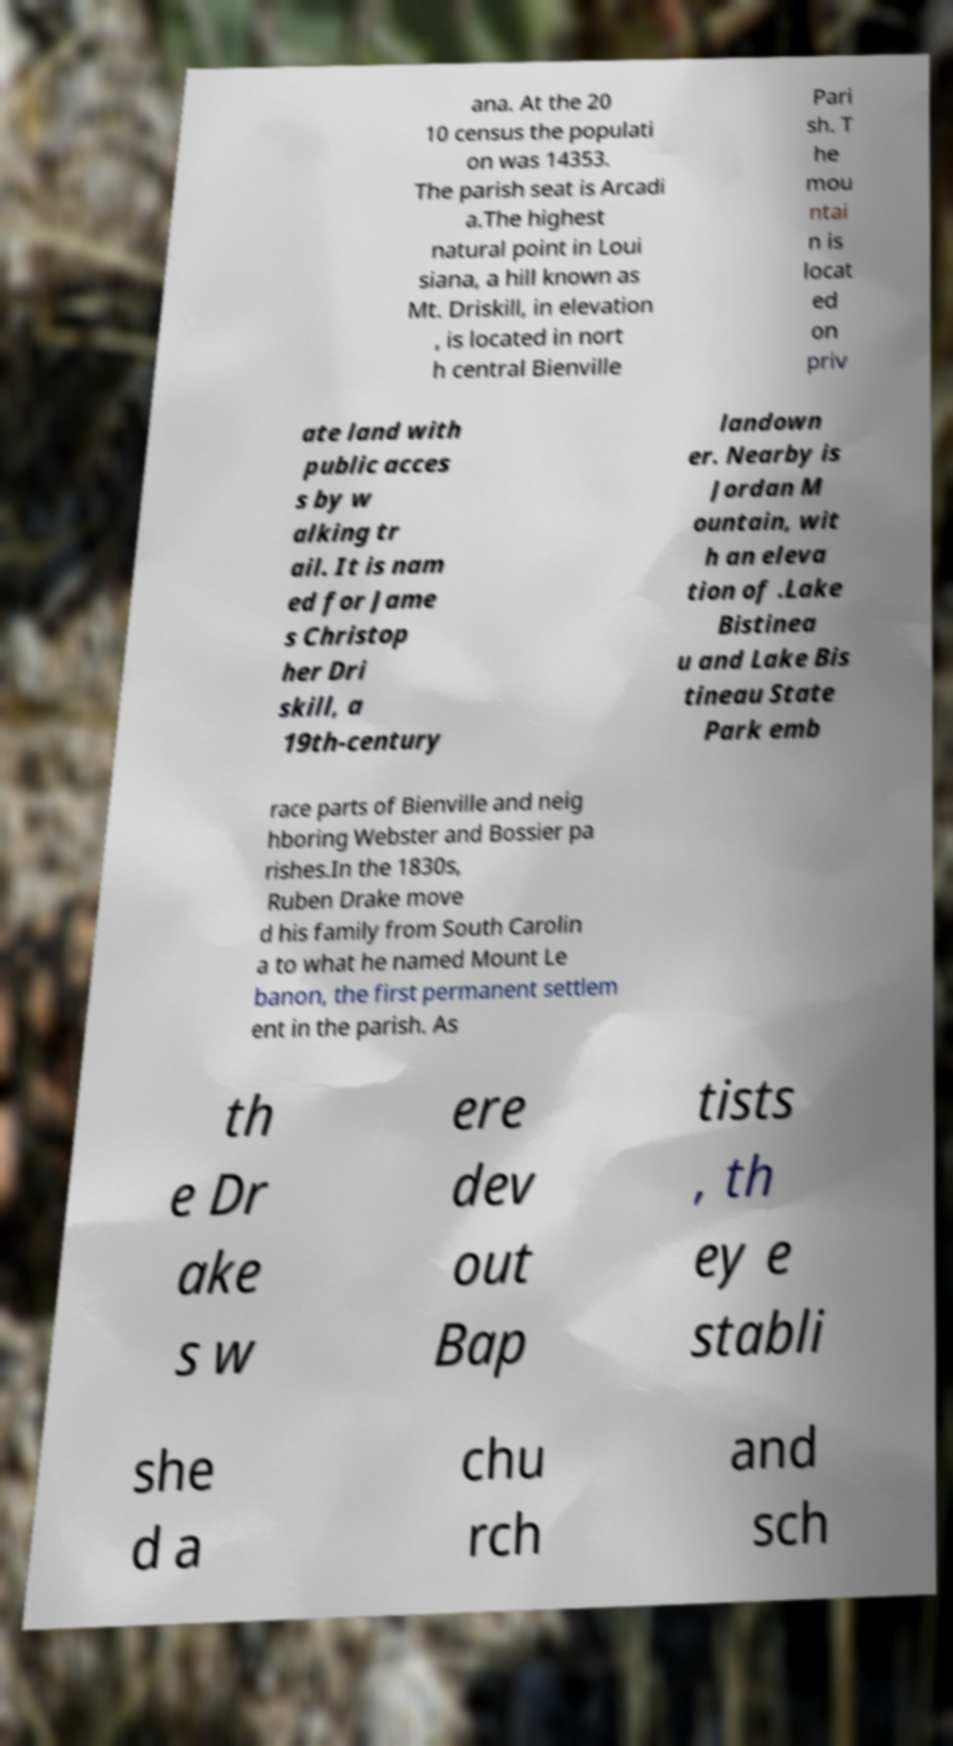Could you extract and type out the text from this image? ana. At the 20 10 census the populati on was 14353. The parish seat is Arcadi a.The highest natural point in Loui siana, a hill known as Mt. Driskill, in elevation , is located in nort h central Bienville Pari sh. T he mou ntai n is locat ed on priv ate land with public acces s by w alking tr ail. It is nam ed for Jame s Christop her Dri skill, a 19th-century landown er. Nearby is Jordan M ountain, wit h an eleva tion of .Lake Bistinea u and Lake Bis tineau State Park emb race parts of Bienville and neig hboring Webster and Bossier pa rishes.In the 1830s, Ruben Drake move d his family from South Carolin a to what he named Mount Le banon, the first permanent settlem ent in the parish. As th e Dr ake s w ere dev out Bap tists , th ey e stabli she d a chu rch and sch 